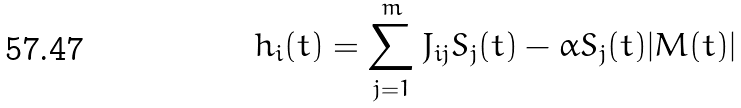Convert formula to latex. <formula><loc_0><loc_0><loc_500><loc_500>h _ { i } ( t ) = \sum ^ { m } _ { j = 1 } J _ { i j } S _ { j } ( t ) - \alpha S _ { j } ( t ) | M ( t ) |</formula> 